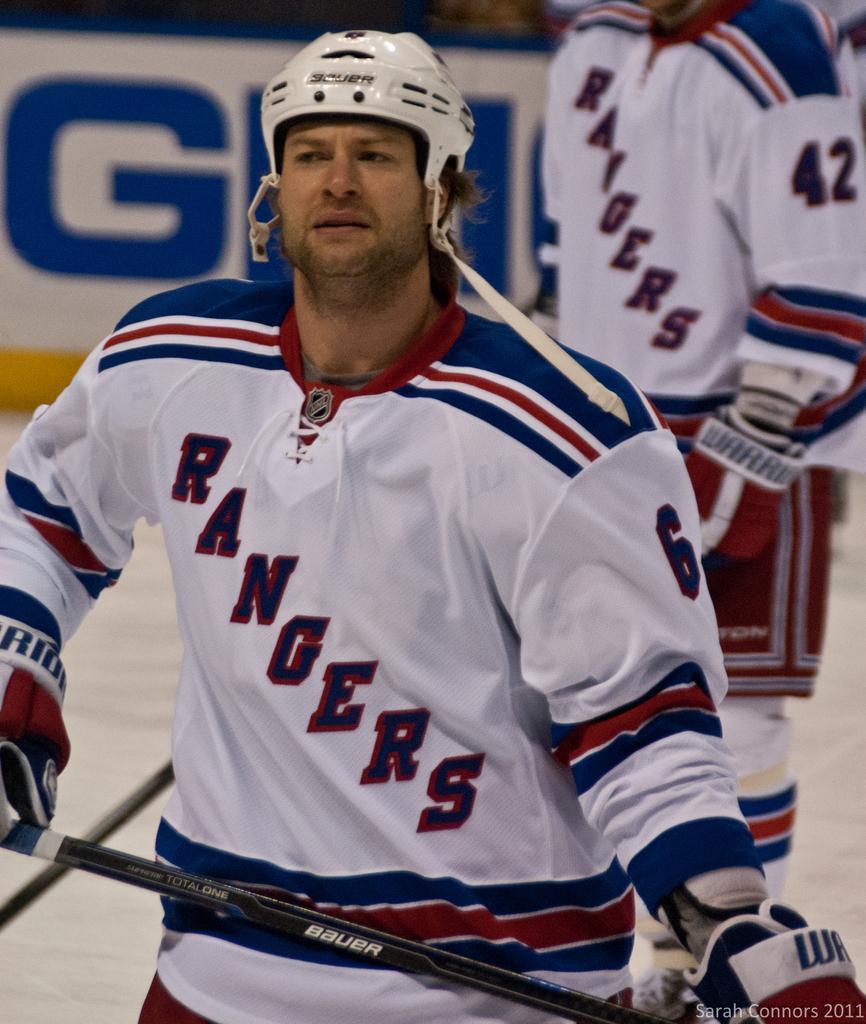In one or two sentences, can you explain what this image depicts? In this picture we can see a man wore a helmet, gloves, holding a stick with his hand and at the back of him we can see a person standing on the ground, poster. 